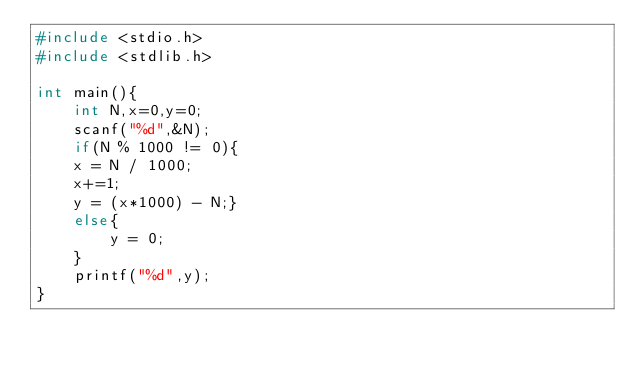<code> <loc_0><loc_0><loc_500><loc_500><_C_>#include <stdio.h>
#include <stdlib.h>

int main(){
    int N,x=0,y=0;
    scanf("%d",&N);
    if(N % 1000 != 0){
    x = N / 1000;
    x+=1;
    y = (x*1000) - N;}
    else{
        y = 0;
    }
    printf("%d",y);
}</code> 